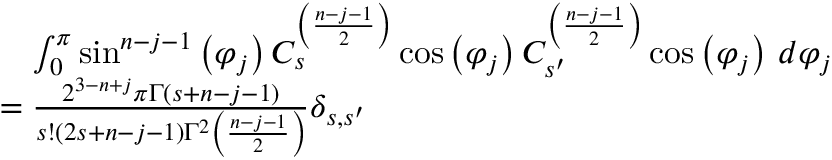Convert formula to latex. <formula><loc_0><loc_0><loc_500><loc_500>{ \begin{array} { r l } & { \quad \int _ { 0 } ^ { \pi } \sin ^ { n - j - 1 } \left ( \varphi _ { j } \right ) C _ { s } ^ { \left ( { \frac { n - j - 1 } { 2 } } \right ) } \cos \left ( \varphi _ { j } \right ) C _ { s ^ { \prime } } ^ { \left ( { \frac { n - j - 1 } { 2 } } \right ) } \cos \left ( \varphi _ { j } \right ) \, d \varphi _ { j } } \\ & { = { \frac { 2 ^ { 3 - n + j } \pi \Gamma ( s + n - j - 1 ) } { s ! ( 2 s + n - j - 1 ) \Gamma ^ { 2 } \left ( { \frac { n - j - 1 } { 2 } } \right ) } } \delta _ { s , s ^ { \prime } } } \end{array} }</formula> 